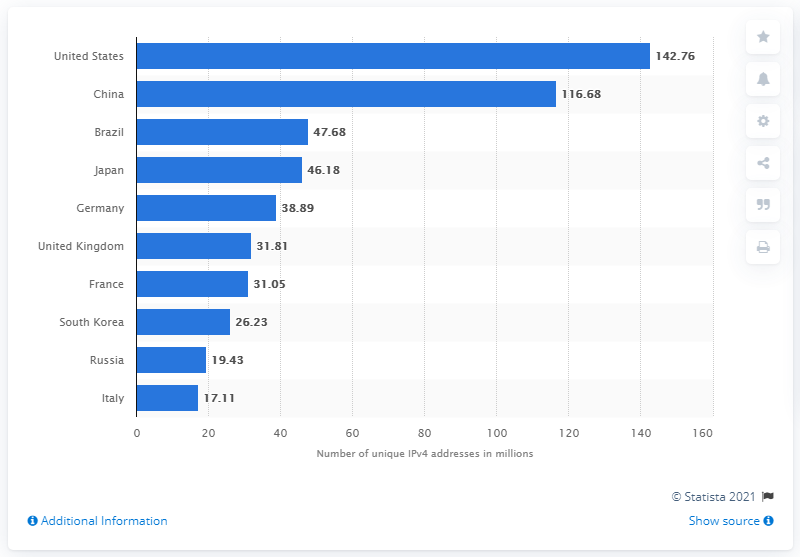Give some essential details in this illustration. During the first quarter of 2017, South Korea had approximately 26.23 million unique IPv4 addresses. 